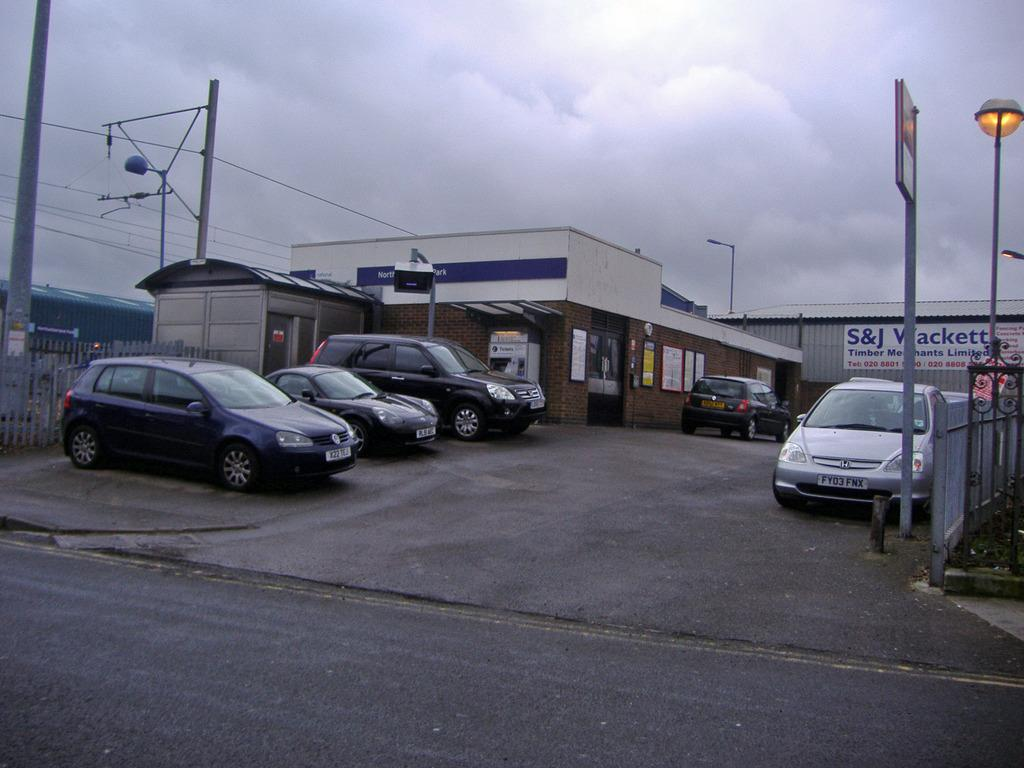What type of vehicles can be seen on the road in the image? There are cars on the road in the image. What structures can be seen in the background of the image? There are sheds in the background of the image. What additional features can be seen in the background of the image? There are lights and poles with wires in the background of the image. What is visible at the top of the image? The sky is visible at the top of the image. Can you tell me where the prison is located in the image? There is no prison present in the image. Is your aunt visible in the image? There is no mention of an aunt in the image, and no person resembling an aunt can be seen. 